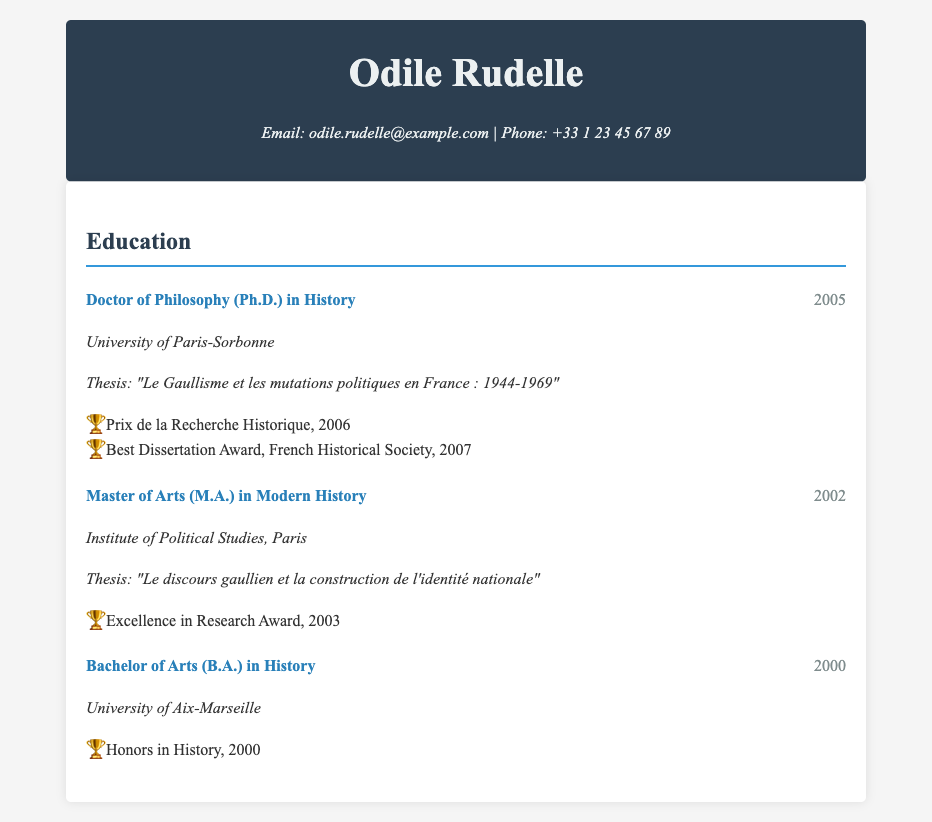What is the title of Odile Rudelle's Ph.D. thesis? The title of her Ph.D. thesis is listed in the document under her education details.
Answer: "Le Gaullisme et les mutations politiques en France : 1944-1969" Which institution did Odile Rudelle attend for her Master's degree? The document specifies the institution where she completed her Master's degree in Modern History.
Answer: Institute of Political Studies, Paris In what year did Odile Rudelle earn her Bachelor of Arts degree? The document provides the year of her completion for the Bachelor of Arts degree in History.
Answer: 2000 What award did she receive in 2006? The document lists awards she received after obtaining her Ph.D., among them the one for 2006.
Answer: Prix de la Recherche Historique What is the subject of her Master's thesis? The subject of her Master's thesis is found in the education section of the document.
Answer: "Le discours gaullien et la construction de l'identité nationale" How many awards did Odile Rudelle receive for her Ph.D. thesis? The document details the awards she received associated with her Ph.D. thesis.
Answer: Two What degree is listed as awarded in 2005? The degree awarded in 2005 is specified in the education section of the CV.
Answer: Doctor of Philosophy (Ph.D.) in History What honors did Odile Rudelle receive for her Bachelor's degree? The document mentions the honors she received upon completing her Bachelor's degree.
Answer: Honors in History 